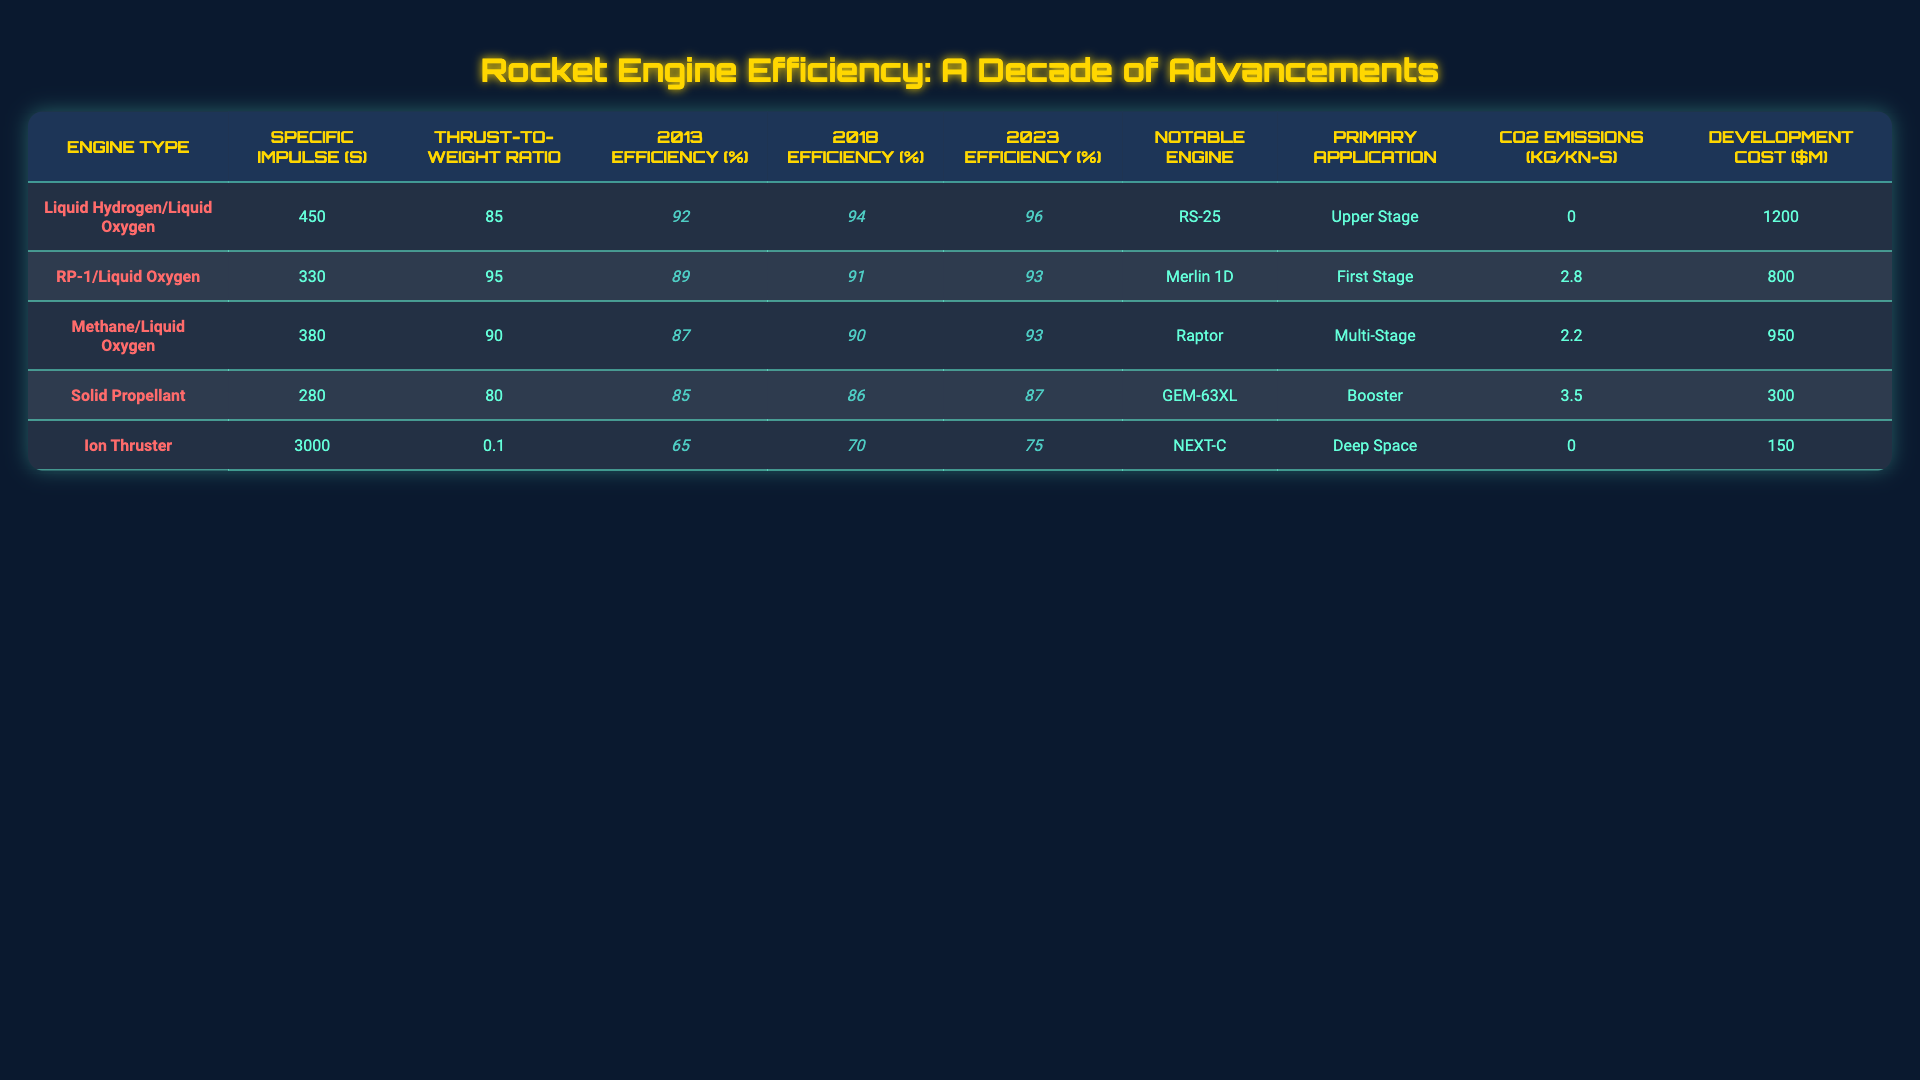What is the most efficient rocket engine in 2023? Looking at the 2023 Efficiency percentages, the Liquid Hydrogen/Liquid Oxygen engine has the highest value at 96%.
Answer: 96% Which rocket engine has the lowest CO2 emissions? The Liquid Hydrogen/Liquid Oxygen and Ion Thruster engines both have 0 kg/kN-s for CO2 emissions, indicating they have the least environmental impact.
Answer: Yes What is the thrust-to-weight ratio of the RP-1/Liquid Oxygen engine? The thrust-to-weight ratio listed for the RP-1/Liquid Oxygen engine is 95.
Answer: 95 Which engine shows the largest increase in efficiency from 2013 to 2023? The Liquid Hydrogen/Liquid Oxygen engine shows an increase from 92% in 2013 to 96% in 2023, which is a 4% increase.
Answer: 4% What is the average efficiency of all engines in 2023? The efficiencies for 2023 are 96, 93, 93, 87, and 75. Summing these gives 444, and dividing by 5 gives an average of 88.8%.
Answer: 88.8% Is there a correlation between the Specific Impulse and the Development Cost? The engines with higher Specific Impulse (like Ion Thruster) tend to have lower Development Costs, whereas the engines with lower Specific Impulse (like RP-1) have higher costs. This suggests a negative correlation.
Answer: Yes What is the thrust-to-weight ratio difference between the Methane/Liquid Oxygen and Solid Propellant engines? The Methane/Liquid Oxygen engine has a thrust-to-weight ratio of 90, while the Solid Propellant engine has a ratio of 80. The difference is 10.
Answer: 10 Which engine type is primarily used for deep space missions? The Ion Thruster engine is designed for deep space applications, as indicated in the Primary Application column.
Answer: Ion Thruster What was the development cost of the RS-25 engine? According to the table, the development cost of the RS-25 engine is $1200 million.
Answer: $1200 million What percentage of CO2 emissions does the Solid Propellant engine have compared to the Methane/Liquid Oxygen engine? The Solid Propellant engine has CO2 emissions of 3.5 kg/kN-s and the Methane/Liquid Oxygen engine has 2.2 kg/kN-s. The Solid Propellant engine has 1.3 kg/kN-s more emissions than the Methane/Liquid Oxygen engine.
Answer: 1.3 kg/kN-s more 